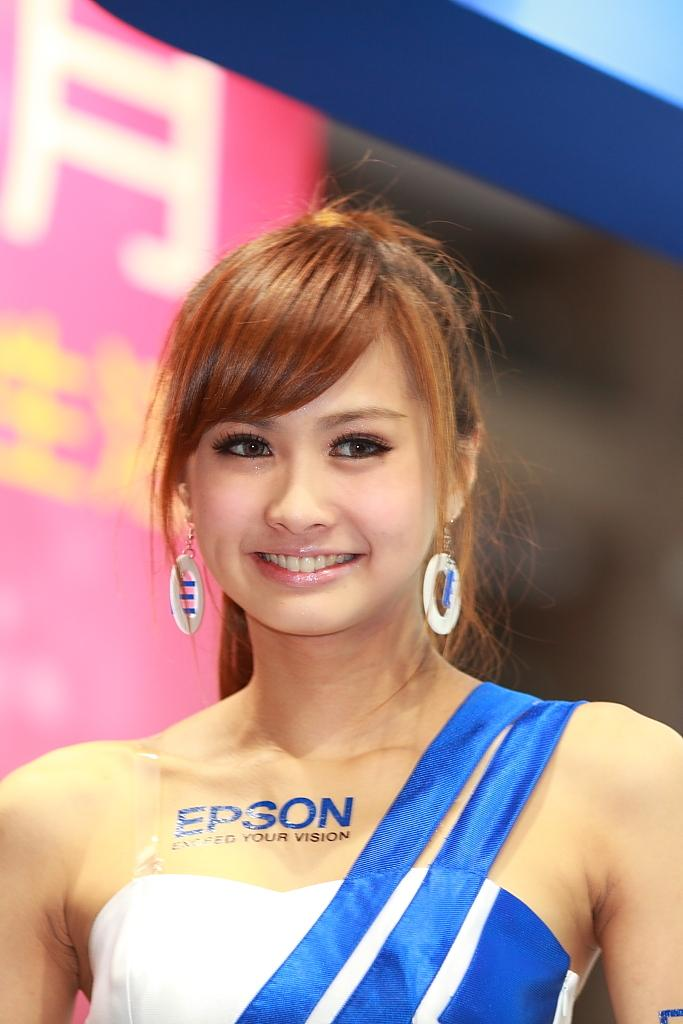Provide a one-sentence caption for the provided image. a lady that has Epson written on her dress. 